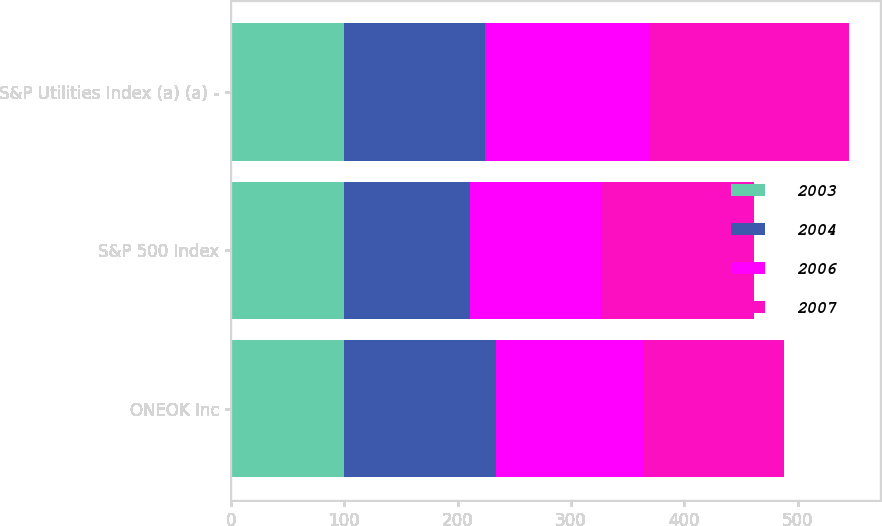Convert chart to OTSL. <chart><loc_0><loc_0><loc_500><loc_500><stacked_bar_chart><ecel><fcel>ONEOK Inc<fcel>S&P 500 Index<fcel>S&P Utilities Index (a) (a) -<nl><fcel>2003<fcel>100<fcel>100<fcel>100<nl><fcel>2004<fcel>133.74<fcel>110.88<fcel>124.28<nl><fcel>2006<fcel>130.01<fcel>116.32<fcel>145.21<nl><fcel>2007<fcel>124.28<fcel>134.69<fcel>175.69<nl></chart> 